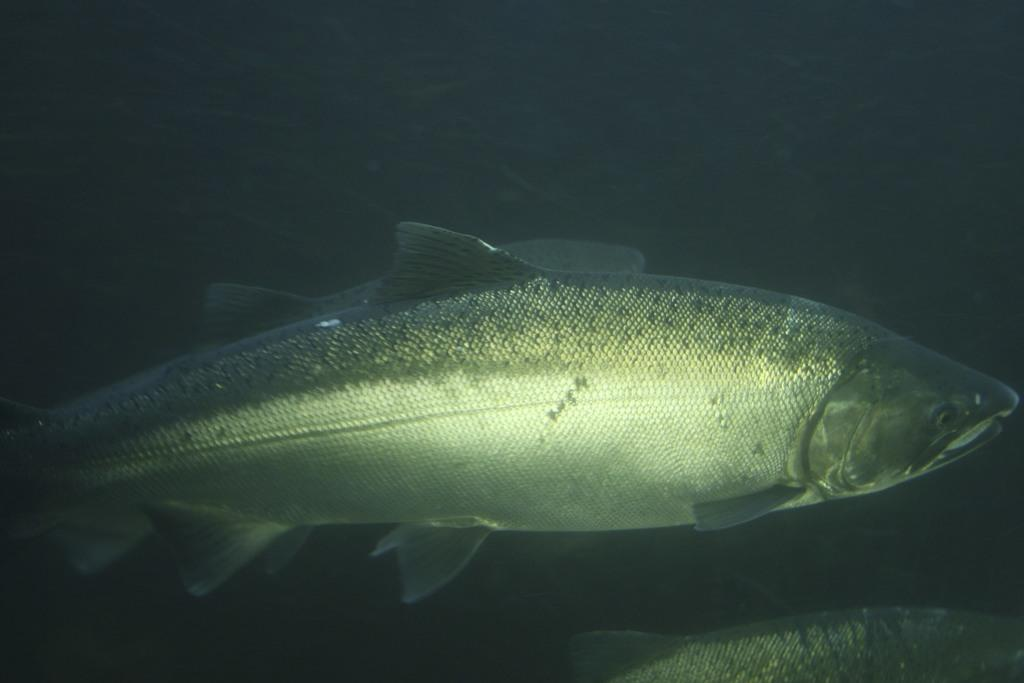What type of animals can be seen in the image? Fishes can be seen in the image. Can you describe the environment where the fishes are located? The image does not provide information about the environment where the fishes are located. How many fishes are visible in the image? The number of fishes visible in the image is not specified in the provided facts. What type of suit is the fish wearing in the image? There is no suit present in the image, as fishes do not wear clothing. 